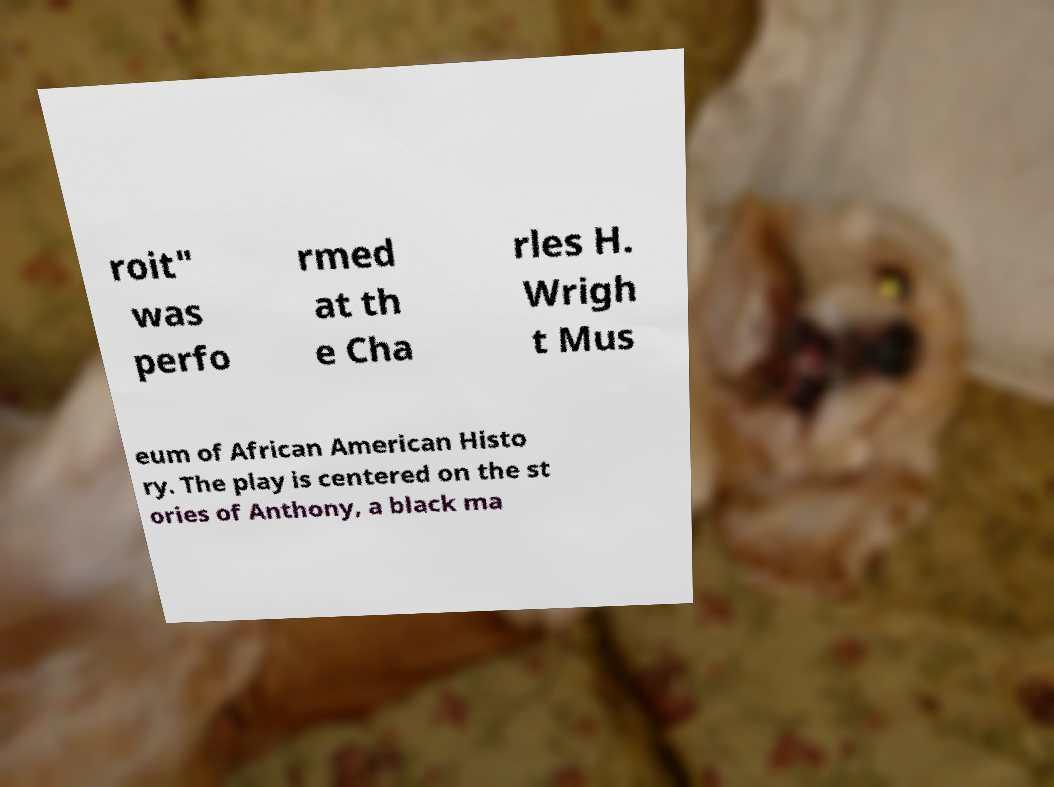Please identify and transcribe the text found in this image. roit" was perfo rmed at th e Cha rles H. Wrigh t Mus eum of African American Histo ry. The play is centered on the st ories of Anthony, a black ma 